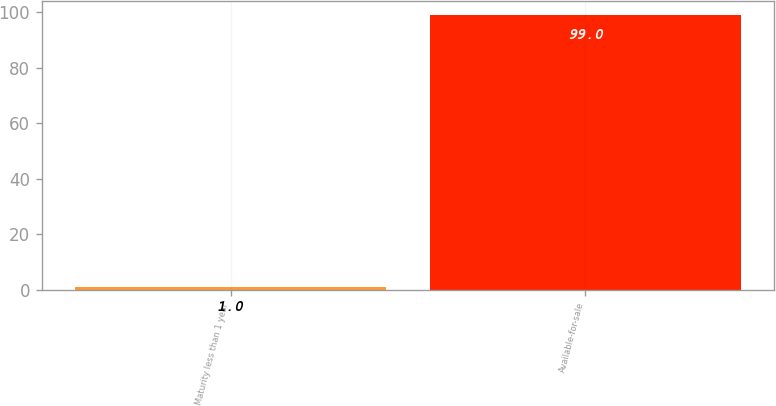<chart> <loc_0><loc_0><loc_500><loc_500><bar_chart><fcel>Maturity less than 1 year<fcel>Available-for-sale<nl><fcel>1<fcel>99<nl></chart> 